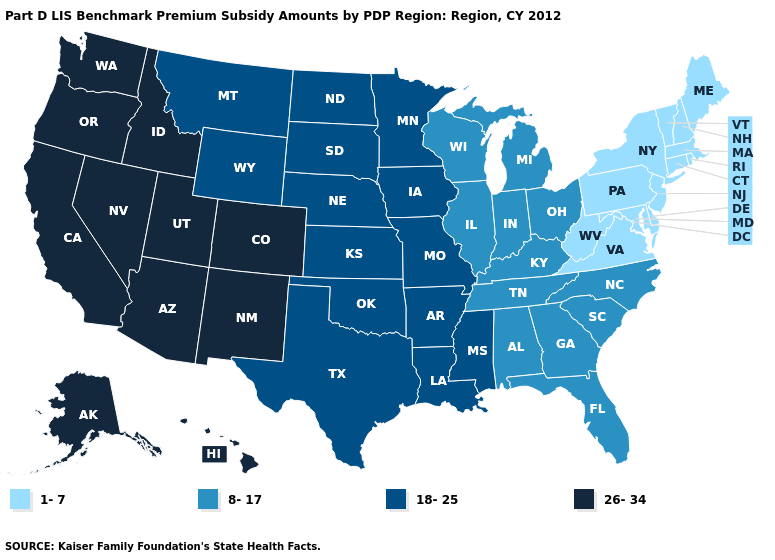Among the states that border Wisconsin , does Iowa have the highest value?
Quick response, please. Yes. Among the states that border Ohio , which have the highest value?
Concise answer only. Indiana, Kentucky, Michigan. What is the value of Iowa?
Give a very brief answer. 18-25. What is the value of Alaska?
Be succinct. 26-34. What is the highest value in the USA?
Short answer required. 26-34. Name the states that have a value in the range 8-17?
Be succinct. Alabama, Florida, Georgia, Illinois, Indiana, Kentucky, Michigan, North Carolina, Ohio, South Carolina, Tennessee, Wisconsin. What is the value of Missouri?
Keep it brief. 18-25. Does Montana have a higher value than Kansas?
Answer briefly. No. How many symbols are there in the legend?
Write a very short answer. 4. What is the value of Hawaii?
Answer briefly. 26-34. Does the map have missing data?
Answer briefly. No. Is the legend a continuous bar?
Quick response, please. No. How many symbols are there in the legend?
Concise answer only. 4. What is the lowest value in the South?
Quick response, please. 1-7. Name the states that have a value in the range 1-7?
Quick response, please. Connecticut, Delaware, Maine, Maryland, Massachusetts, New Hampshire, New Jersey, New York, Pennsylvania, Rhode Island, Vermont, Virginia, West Virginia. 